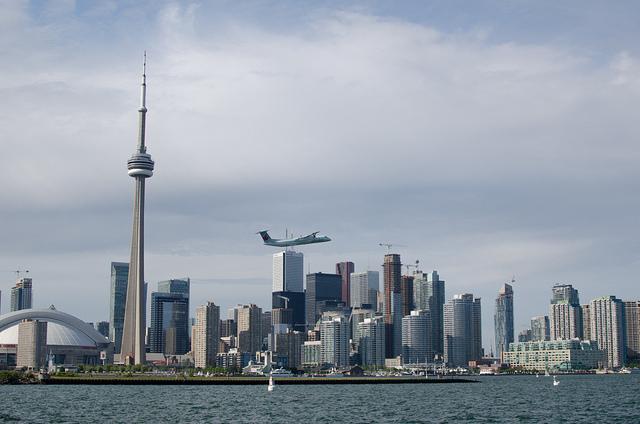Is the city in silhouette?
Give a very brief answer. No. What city is this?
Quick response, please. Seattle. Could there be a control tower?
Quick response, please. Yes. What city is shown?
Keep it brief. Seattle. How many buildings are there?
Short answer required. 20. What famous landmark is this?
Write a very short answer. Space needle. Which building is the tallest?
Answer briefly. Needle. What is the historic building?
Quick response, please. Space needle. Is the plane going to land soon?
Be succinct. Yes. Is this Seattle?
Write a very short answer. Yes. What body of water is that?
Short answer required. River. What country was this photo taken in?
Keep it brief. Canada. What is the name of this river?
Concise answer only. Hudson. What is flying in the air?
Short answer required. Airplane. What river is this?
Keep it brief. Hudson. What city skyline is this a picture of?
Answer briefly. Seattle. Is it night time?
Short answer required. No. What city skyline is this?
Write a very short answer. Seattle. Where is this?
Answer briefly. Seattle. Is there a plane in the sky?
Be succinct. Yes. Is the plane flying too close to the buildings?
Concise answer only. Yes. What city is this in?
Short answer required. Seattle. Who big is this landmark?
Be succinct. Very. 